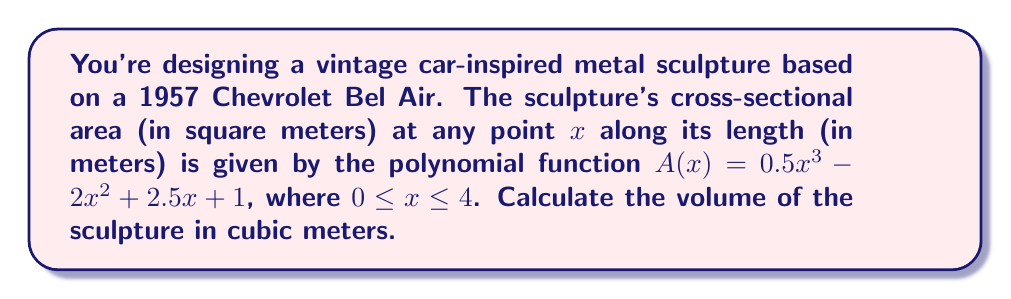Can you solve this math problem? To find the volume of the sculpture, we need to integrate the cross-sectional area function $A(x)$ over the length of the sculpture:

1) The volume is given by the definite integral:
   $$V = \int_0^4 A(x) dx = \int_0^4 (0.5x^3 - 2x^2 + 2.5x + 1) dx$$

2) Integrate each term:
   $$V = \left[\frac{0.5x^4}{4} - \frac{2x^3}{3} + \frac{2.5x^2}{2} + x\right]_0^4$$

3) Evaluate the antiderivative at the upper and lower bounds:
   $$V = \left(\frac{0.5(4^4)}{4} - \frac{2(4^3)}{3} + \frac{2.5(4^2)}{2} + 4\right) - \left(\frac{0.5(0^4)}{4} - \frac{2(0^3)}{3} + \frac{2.5(0^2)}{2} + 0\right)$$

4) Simplify:
   $$V = (32 - \frac{128}{3} + 20 + 4) - 0 = 56 - \frac{128}{3} = \frac{168 - 128}{3} = \frac{40}{3}$$

Therefore, the volume of the sculpture is $\frac{40}{3}$ cubic meters.
Answer: $\frac{40}{3}$ m³ 